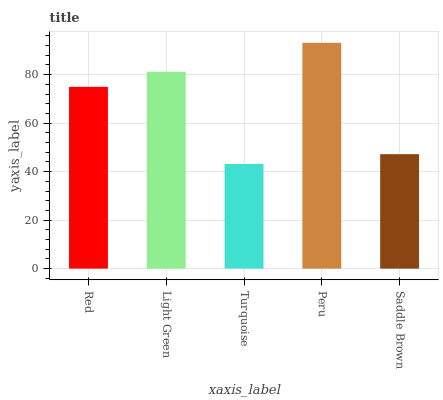Is Turquoise the minimum?
Answer yes or no. Yes. Is Peru the maximum?
Answer yes or no. Yes. Is Light Green the minimum?
Answer yes or no. No. Is Light Green the maximum?
Answer yes or no. No. Is Light Green greater than Red?
Answer yes or no. Yes. Is Red less than Light Green?
Answer yes or no. Yes. Is Red greater than Light Green?
Answer yes or no. No. Is Light Green less than Red?
Answer yes or no. No. Is Red the high median?
Answer yes or no. Yes. Is Red the low median?
Answer yes or no. Yes. Is Saddle Brown the high median?
Answer yes or no. No. Is Peru the low median?
Answer yes or no. No. 